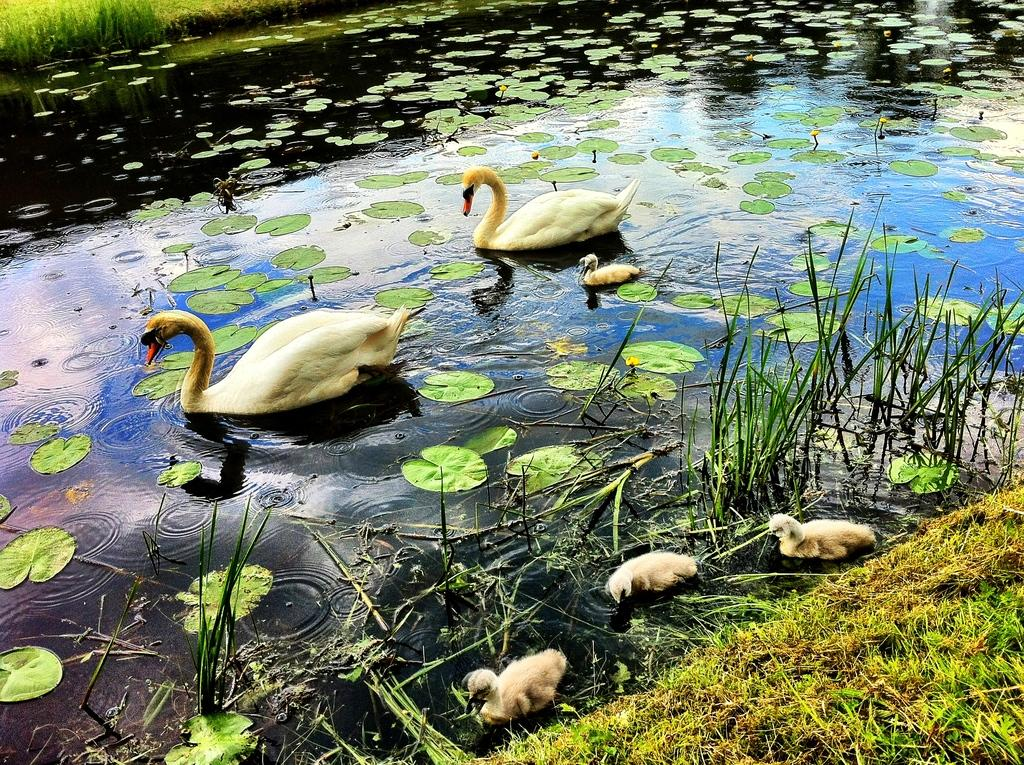What animals can be seen in the image? There are two swans in the image. What are the swans doing in the image? The swans are swimming in the water. What else can be seen in the water besides the swans? There are lotus leaves in the water. What type of hammer can be seen in the image? There is no hammer present in the image; it features two swans swimming in the water with lotus leaves. 